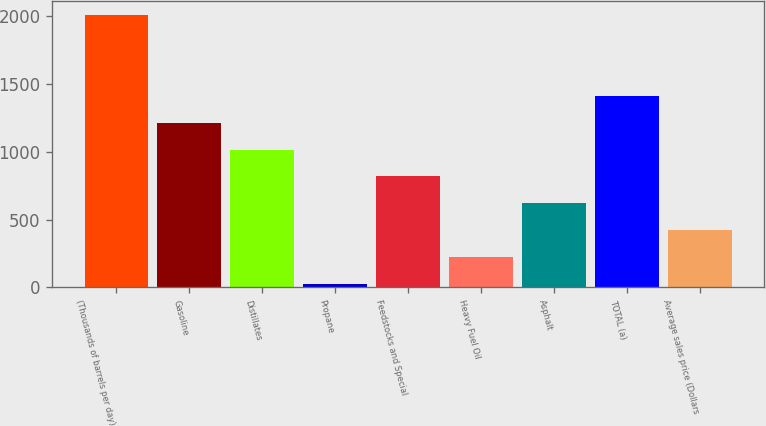Convert chart. <chart><loc_0><loc_0><loc_500><loc_500><bar_chart><fcel>(Thousands of barrels per day)<fcel>Gasoline<fcel>Distillates<fcel>Propane<fcel>Feedstocks and Special<fcel>Heavy Fuel Oil<fcel>Asphalt<fcel>TOTAL (a)<fcel>Average sales price (Dollars<nl><fcel>2007<fcel>1213.4<fcel>1015<fcel>23<fcel>816.6<fcel>221.4<fcel>618.2<fcel>1411.8<fcel>419.8<nl></chart> 